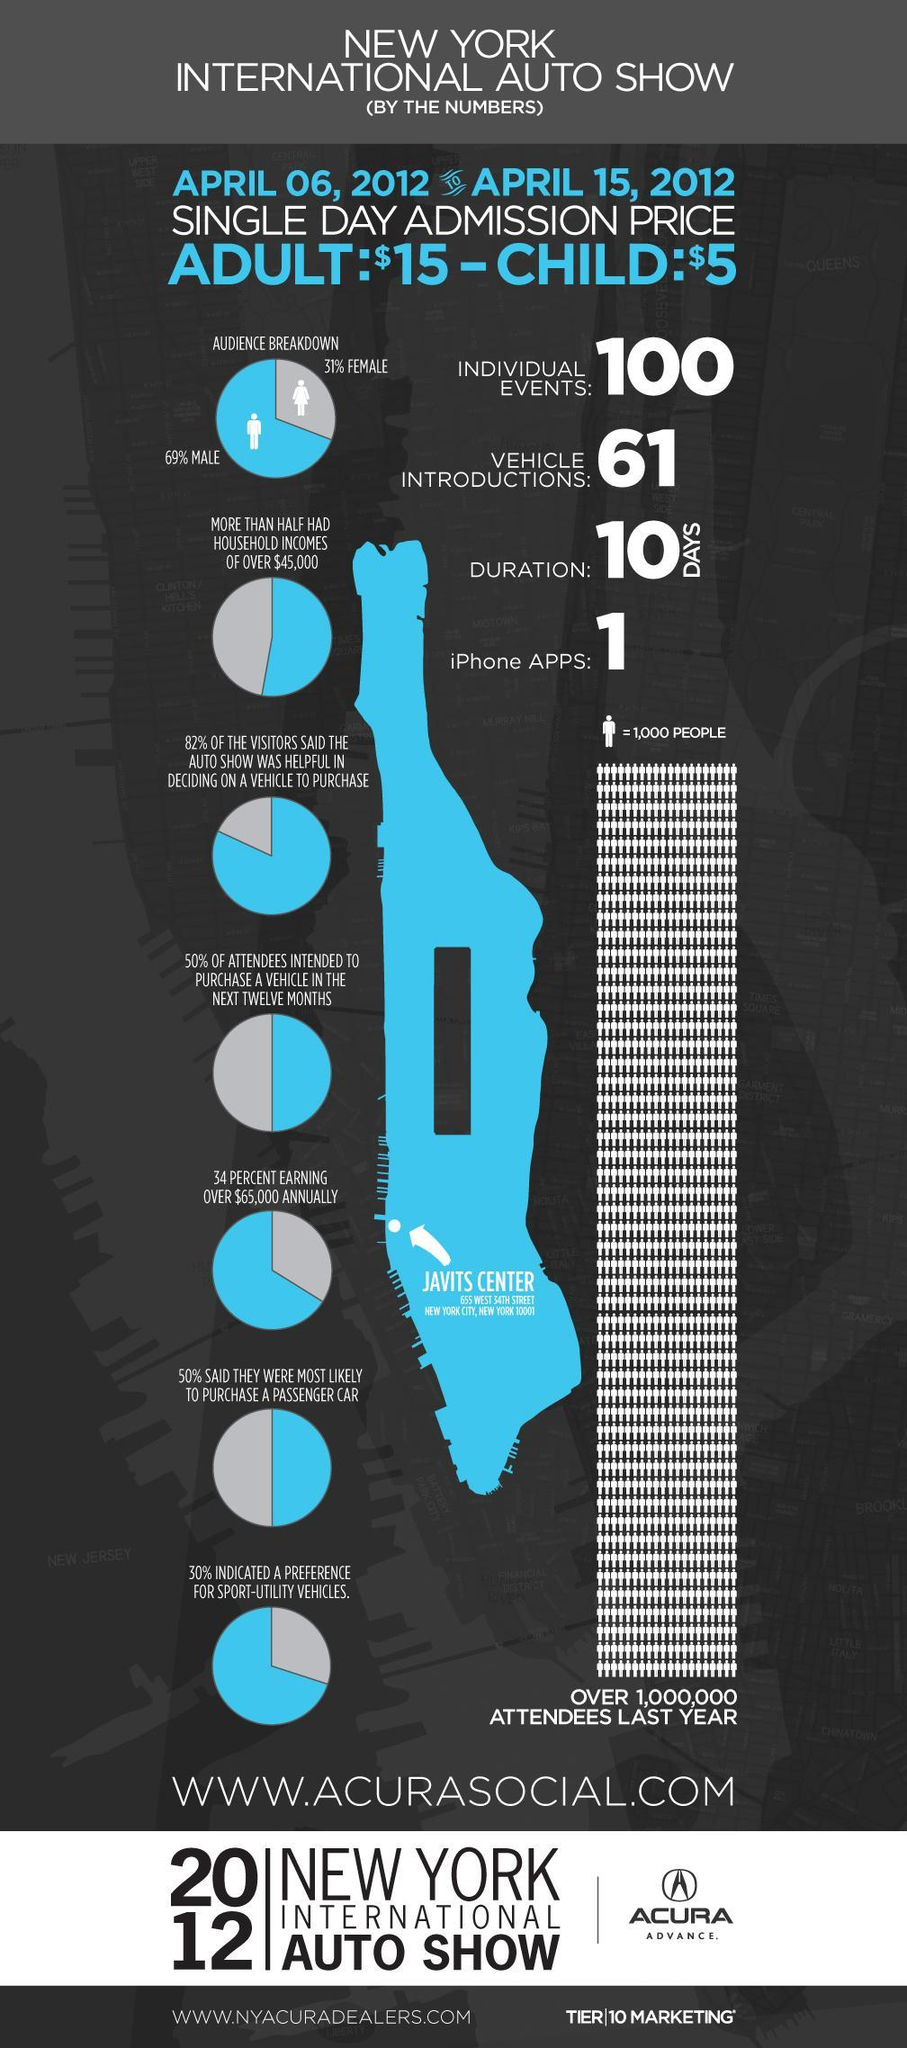What percent of the visitors didn't say that the auto show was helpful in deciding on a vehicle to purchase?
Answer the question with a short phrase. 18% What percent of women attended the New York International Auto Show? 31% What percent of men attended the New York International Auto Show? 69% What was the duration of the New York International Auto Show conducted in 2012? 10 DAYS How many vehicles introductions were done in the New York International Auto Show? 61 